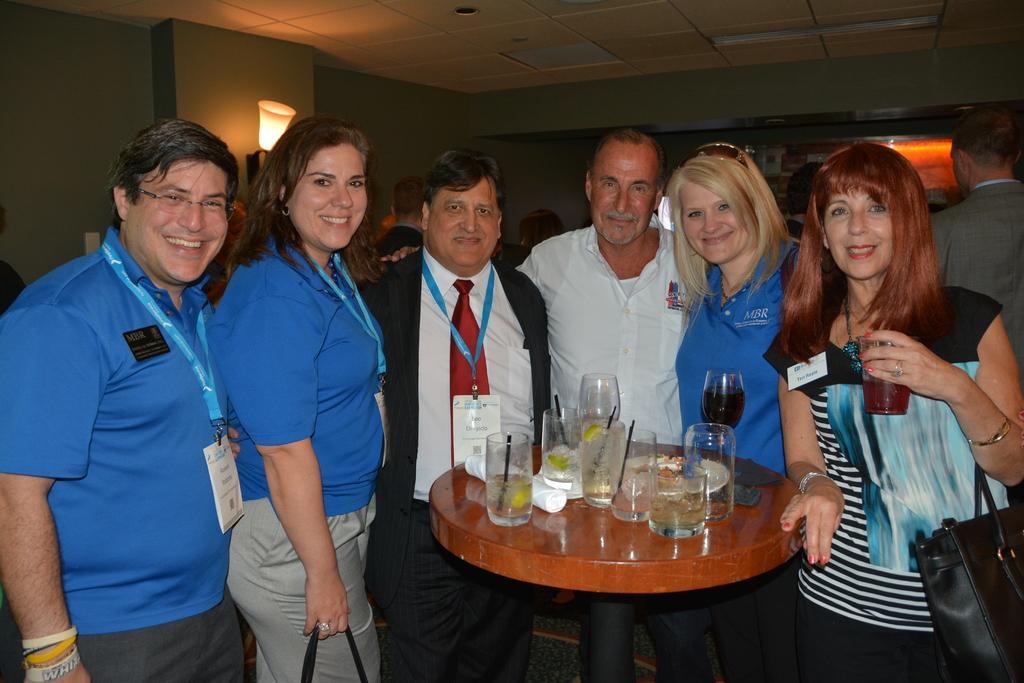Could you give a brief overview of what you see in this image? This image is clicked in a room. there is light on the top. There are 6 people standing around the table which is in the middle. There are so many glasses on that table and tissue rolls. Three of them are women and three of them are men. The one who is on the right side is holding bag. Three of them who are on left side are wearing ID cards. 